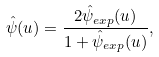Convert formula to latex. <formula><loc_0><loc_0><loc_500><loc_500>\hat { \psi } ( u ) = \frac { 2 \hat { \psi } _ { e x p } ( u ) } { 1 + \hat { \psi } _ { e x p } ( u ) } ,</formula> 